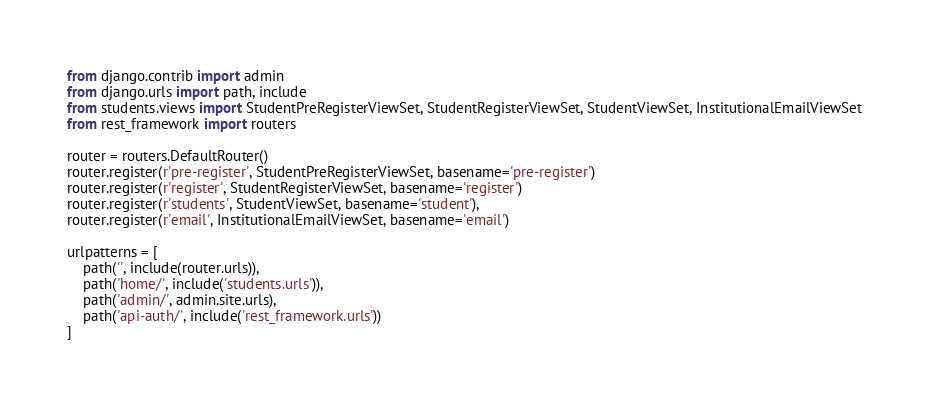Convert code to text. <code><loc_0><loc_0><loc_500><loc_500><_Python_>from django.contrib import admin
from django.urls import path, include
from students.views import StudentPreRegisterViewSet, StudentRegisterViewSet, StudentViewSet, InstitutionalEmailViewSet    
from rest_framework import routers

router = routers.DefaultRouter()
router.register(r'pre-register', StudentPreRegisterViewSet, basename='pre-register')
router.register(r'register', StudentRegisterViewSet, basename='register')
router.register(r'students', StudentViewSet, basename='student'),
router.register(r'email', InstitutionalEmailViewSet, basename='email')

urlpatterns = [
    path('', include(router.urls)),
    path('home/', include('students.urls')),
    path('admin/', admin.site.urls),
    path('api-auth/', include('rest_framework.urls'))
]
</code> 